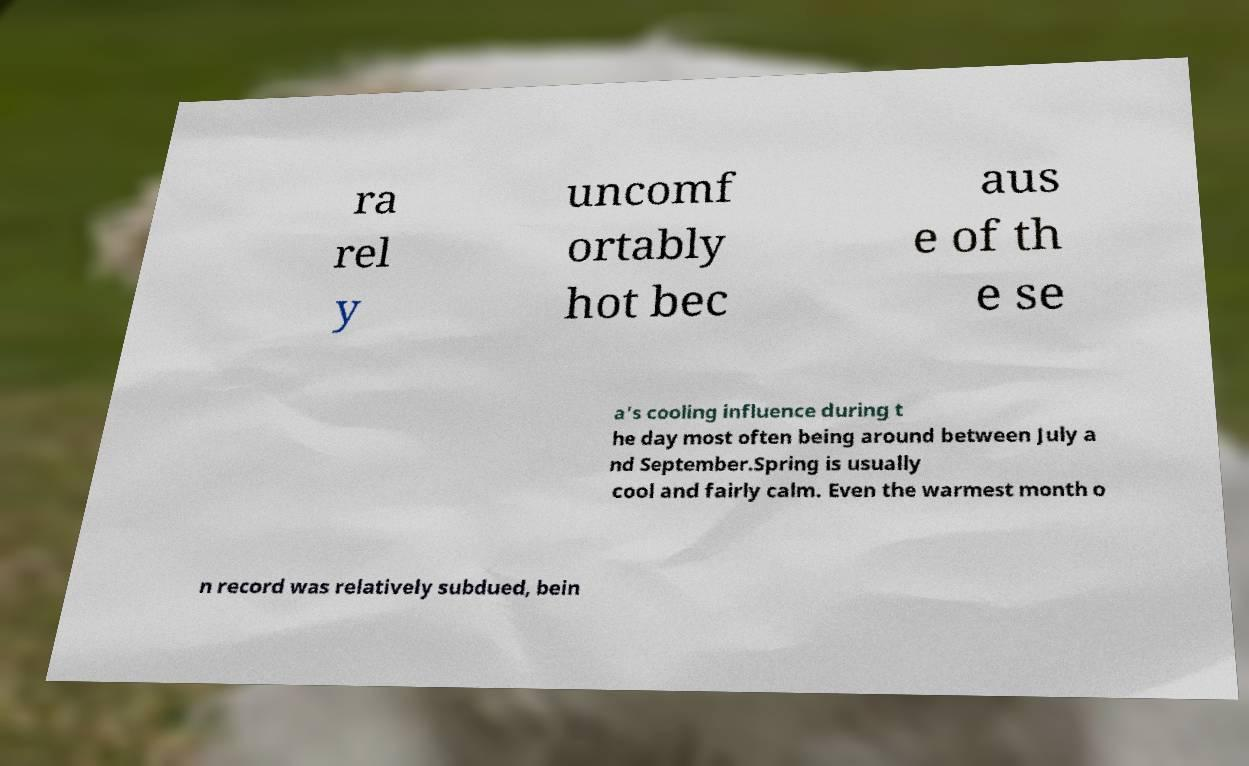What messages or text are displayed in this image? I need them in a readable, typed format. ra rel y uncomf ortably hot bec aus e of th e se a's cooling influence during t he day most often being around between July a nd September.Spring is usually cool and fairly calm. Even the warmest month o n record was relatively subdued, bein 